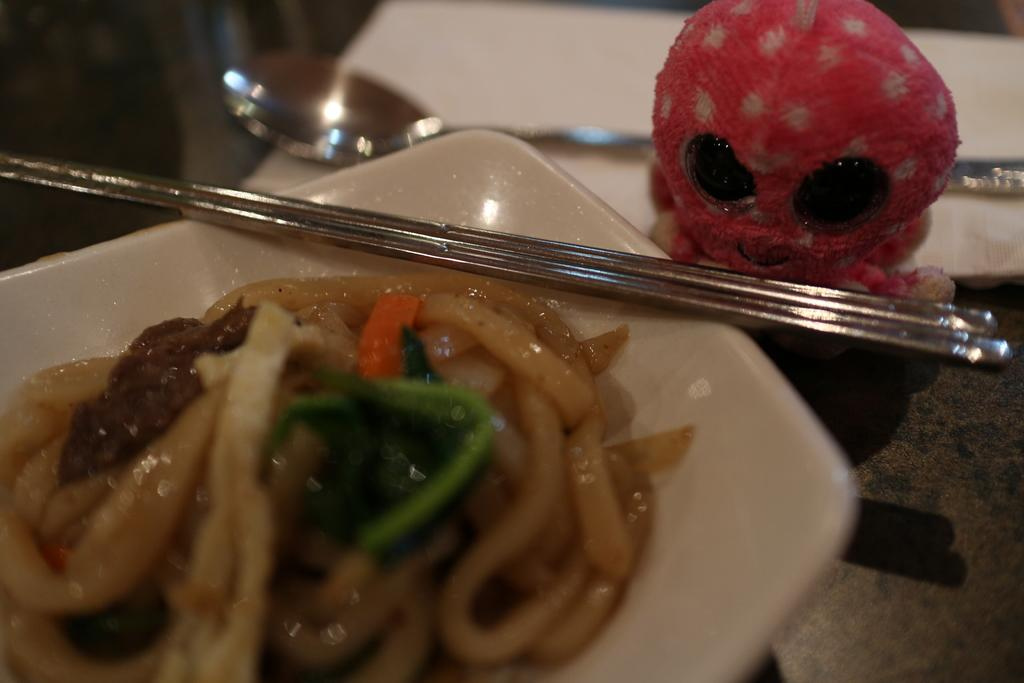What type of food is in the plate that is visible in the image? There are noodles in a plate in the image. What utensils are present on the table in the image? Chopsticks are present on the table in the image. Are there any other plates visible in the image? Yes, there is another plate in the image. What is on the second plate? A spoon and a toy are present on the second plate. Can you see any silk threads in the image? There is no silk or silk threads present in the image. 